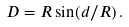<formula> <loc_0><loc_0><loc_500><loc_500>D = R \sin ( d / R ) \, .</formula> 